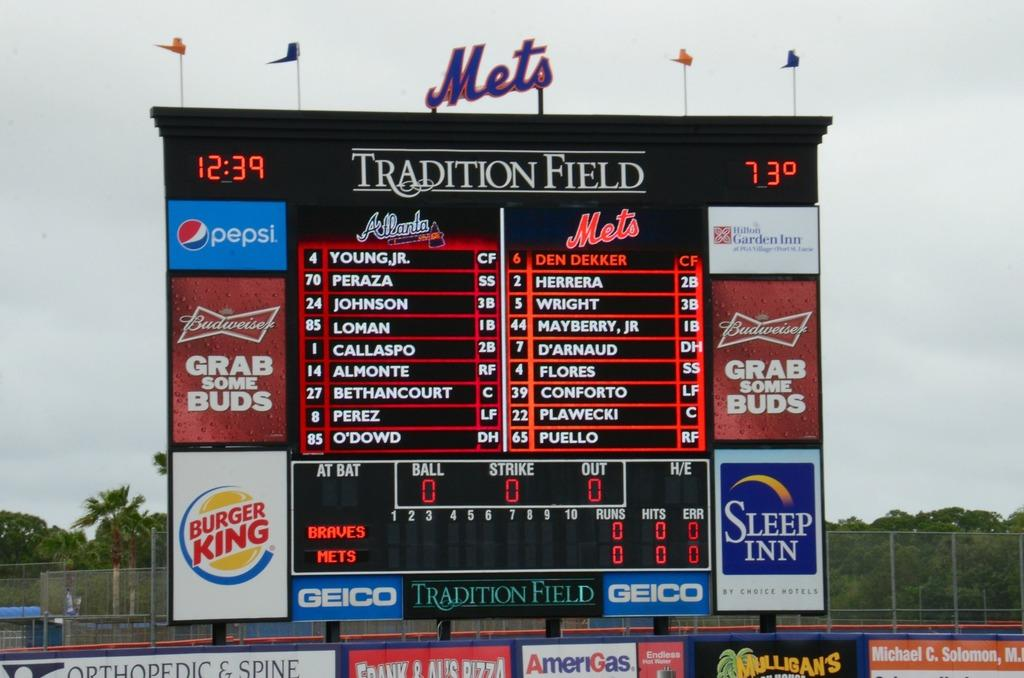<image>
Offer a succinct explanation of the picture presented. A large sign has the Mets logo on top. 